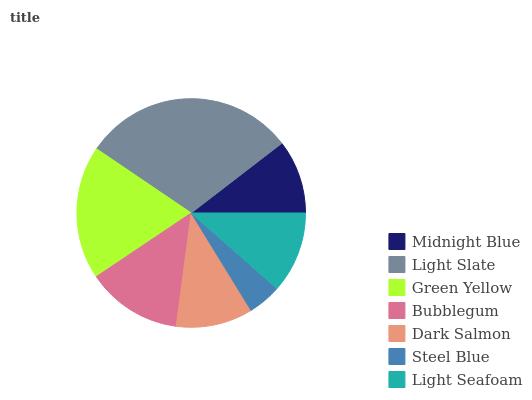Is Steel Blue the minimum?
Answer yes or no. Yes. Is Light Slate the maximum?
Answer yes or no. Yes. Is Green Yellow the minimum?
Answer yes or no. No. Is Green Yellow the maximum?
Answer yes or no. No. Is Light Slate greater than Green Yellow?
Answer yes or no. Yes. Is Green Yellow less than Light Slate?
Answer yes or no. Yes. Is Green Yellow greater than Light Slate?
Answer yes or no. No. Is Light Slate less than Green Yellow?
Answer yes or no. No. Is Light Seafoam the high median?
Answer yes or no. Yes. Is Light Seafoam the low median?
Answer yes or no. Yes. Is Light Slate the high median?
Answer yes or no. No. Is Steel Blue the low median?
Answer yes or no. No. 